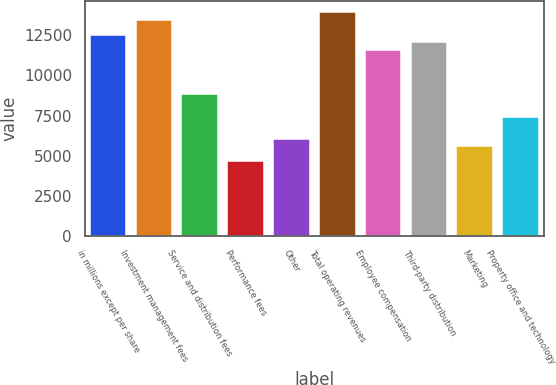Convert chart. <chart><loc_0><loc_0><loc_500><loc_500><bar_chart><fcel>in millions except per share<fcel>Investment management fees<fcel>Service and distribution fees<fcel>Performance fees<fcel>Other<fcel>Total operating revenues<fcel>Employee compensation<fcel>Third-party distribution<fcel>Marketing<fcel>Property office and technology<nl><fcel>12539<fcel>13467.7<fcel>8823.98<fcel>4644.61<fcel>6037.73<fcel>13932.1<fcel>11610.2<fcel>12074.6<fcel>5573.35<fcel>7430.85<nl></chart> 